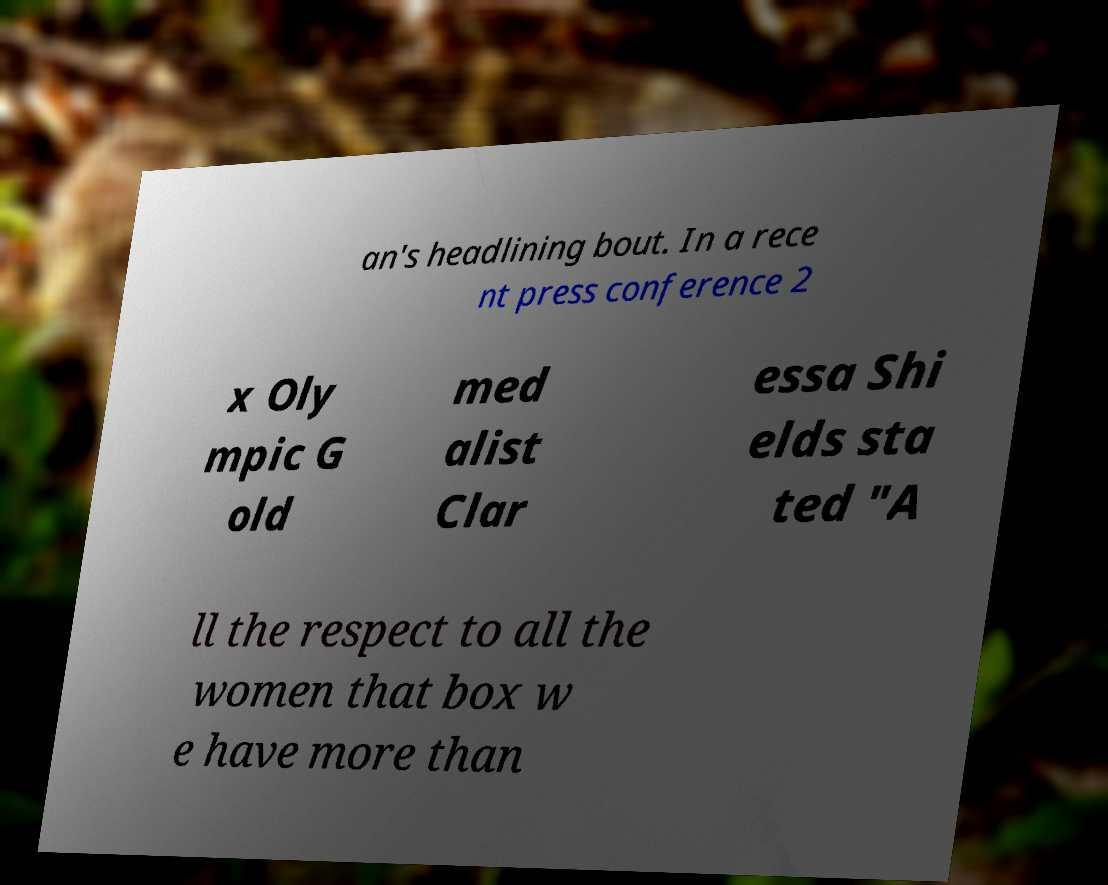What messages or text are displayed in this image? I need them in a readable, typed format. an's headlining bout. In a rece nt press conference 2 x Oly mpic G old med alist Clar essa Shi elds sta ted "A ll the respect to all the women that box w e have more than 